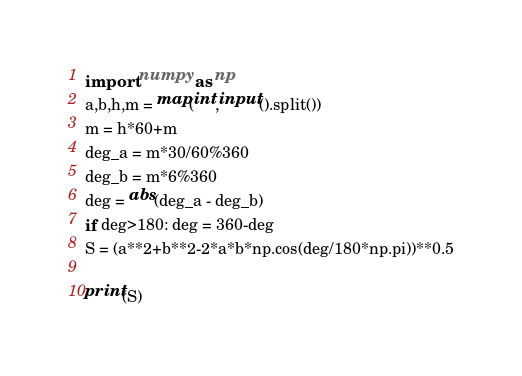<code> <loc_0><loc_0><loc_500><loc_500><_Python_>import numpy as np
a,b,h,m = map(int,input().split())
m = h*60+m
deg_a = m*30/60%360
deg_b = m*6%360
deg = abs(deg_a - deg_b)
if deg>180: deg = 360-deg
S = (a**2+b**2-2*a*b*np.cos(deg/180*np.pi))**0.5

print(S)</code> 